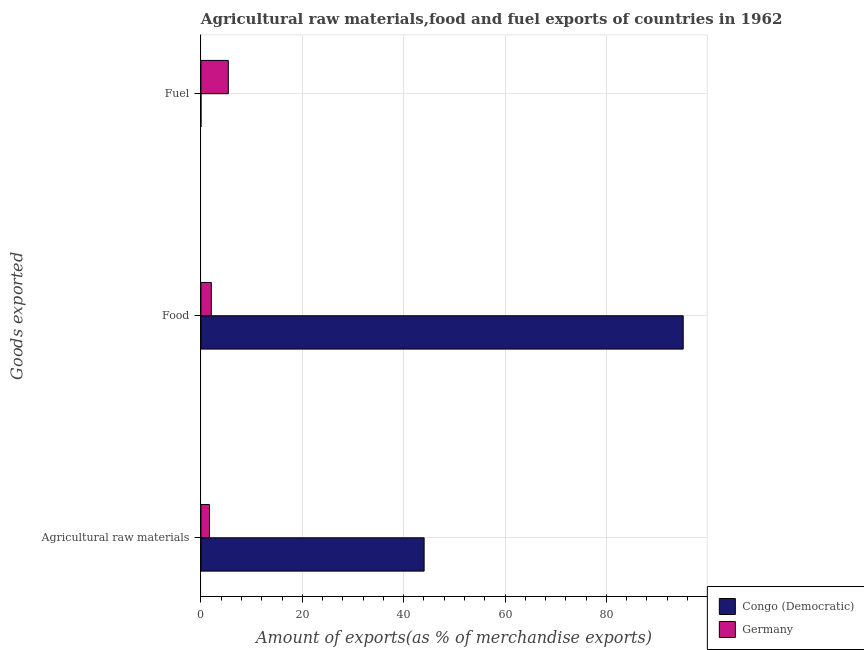How many different coloured bars are there?
Give a very brief answer. 2. Are the number of bars per tick equal to the number of legend labels?
Offer a terse response. Yes. Are the number of bars on each tick of the Y-axis equal?
Provide a short and direct response. Yes. How many bars are there on the 2nd tick from the top?
Offer a very short reply. 2. How many bars are there on the 3rd tick from the bottom?
Give a very brief answer. 2. What is the label of the 2nd group of bars from the top?
Provide a succinct answer. Food. What is the percentage of raw materials exports in Congo (Democratic)?
Provide a succinct answer. 44.04. Across all countries, what is the maximum percentage of raw materials exports?
Keep it short and to the point. 44.04. Across all countries, what is the minimum percentage of fuel exports?
Offer a very short reply. 0. In which country was the percentage of raw materials exports maximum?
Make the answer very short. Congo (Democratic). In which country was the percentage of food exports minimum?
Ensure brevity in your answer.  Germany. What is the total percentage of fuel exports in the graph?
Keep it short and to the point. 5.41. What is the difference between the percentage of fuel exports in Congo (Democratic) and that in Germany?
Provide a succinct answer. -5.4. What is the difference between the percentage of fuel exports in Germany and the percentage of raw materials exports in Congo (Democratic)?
Provide a succinct answer. -38.63. What is the average percentage of fuel exports per country?
Provide a succinct answer. 2.7. What is the difference between the percentage of fuel exports and percentage of food exports in Congo (Democratic)?
Ensure brevity in your answer.  -95.15. In how many countries, is the percentage of food exports greater than 52 %?
Offer a very short reply. 1. What is the ratio of the percentage of fuel exports in Congo (Democratic) to that in Germany?
Give a very brief answer. 0. Is the percentage of fuel exports in Germany less than that in Congo (Democratic)?
Offer a very short reply. No. Is the difference between the percentage of raw materials exports in Congo (Democratic) and Germany greater than the difference between the percentage of food exports in Congo (Democratic) and Germany?
Keep it short and to the point. No. What is the difference between the highest and the second highest percentage of fuel exports?
Your answer should be compact. 5.4. What is the difference between the highest and the lowest percentage of raw materials exports?
Your answer should be very brief. 42.35. What does the 2nd bar from the bottom in Food represents?
Make the answer very short. Germany. Are the values on the major ticks of X-axis written in scientific E-notation?
Keep it short and to the point. No. Does the graph contain any zero values?
Your answer should be very brief. No. Where does the legend appear in the graph?
Offer a very short reply. Bottom right. How many legend labels are there?
Your answer should be very brief. 2. What is the title of the graph?
Make the answer very short. Agricultural raw materials,food and fuel exports of countries in 1962. What is the label or title of the X-axis?
Provide a succinct answer. Amount of exports(as % of merchandise exports). What is the label or title of the Y-axis?
Provide a succinct answer. Goods exported. What is the Amount of exports(as % of merchandise exports) of Congo (Democratic) in Agricultural raw materials?
Offer a very short reply. 44.04. What is the Amount of exports(as % of merchandise exports) in Germany in Agricultural raw materials?
Provide a succinct answer. 1.69. What is the Amount of exports(as % of merchandise exports) in Congo (Democratic) in Food?
Your answer should be compact. 95.15. What is the Amount of exports(as % of merchandise exports) in Germany in Food?
Provide a short and direct response. 2.05. What is the Amount of exports(as % of merchandise exports) in Congo (Democratic) in Fuel?
Provide a short and direct response. 0. What is the Amount of exports(as % of merchandise exports) of Germany in Fuel?
Give a very brief answer. 5.4. Across all Goods exported, what is the maximum Amount of exports(as % of merchandise exports) of Congo (Democratic)?
Your answer should be very brief. 95.15. Across all Goods exported, what is the maximum Amount of exports(as % of merchandise exports) in Germany?
Your answer should be very brief. 5.4. Across all Goods exported, what is the minimum Amount of exports(as % of merchandise exports) in Congo (Democratic)?
Provide a short and direct response. 0. Across all Goods exported, what is the minimum Amount of exports(as % of merchandise exports) in Germany?
Your answer should be compact. 1.69. What is the total Amount of exports(as % of merchandise exports) in Congo (Democratic) in the graph?
Keep it short and to the point. 139.19. What is the total Amount of exports(as % of merchandise exports) in Germany in the graph?
Ensure brevity in your answer.  9.15. What is the difference between the Amount of exports(as % of merchandise exports) of Congo (Democratic) in Agricultural raw materials and that in Food?
Make the answer very short. -51.12. What is the difference between the Amount of exports(as % of merchandise exports) in Germany in Agricultural raw materials and that in Food?
Your response must be concise. -0.36. What is the difference between the Amount of exports(as % of merchandise exports) in Congo (Democratic) in Agricultural raw materials and that in Fuel?
Your response must be concise. 44.04. What is the difference between the Amount of exports(as % of merchandise exports) of Germany in Agricultural raw materials and that in Fuel?
Your answer should be very brief. -3.71. What is the difference between the Amount of exports(as % of merchandise exports) of Congo (Democratic) in Food and that in Fuel?
Make the answer very short. 95.15. What is the difference between the Amount of exports(as % of merchandise exports) of Germany in Food and that in Fuel?
Ensure brevity in your answer.  -3.35. What is the difference between the Amount of exports(as % of merchandise exports) in Congo (Democratic) in Agricultural raw materials and the Amount of exports(as % of merchandise exports) in Germany in Food?
Your answer should be compact. 41.99. What is the difference between the Amount of exports(as % of merchandise exports) of Congo (Democratic) in Agricultural raw materials and the Amount of exports(as % of merchandise exports) of Germany in Fuel?
Keep it short and to the point. 38.63. What is the difference between the Amount of exports(as % of merchandise exports) in Congo (Democratic) in Food and the Amount of exports(as % of merchandise exports) in Germany in Fuel?
Offer a very short reply. 89.75. What is the average Amount of exports(as % of merchandise exports) of Congo (Democratic) per Goods exported?
Make the answer very short. 46.4. What is the average Amount of exports(as % of merchandise exports) of Germany per Goods exported?
Give a very brief answer. 3.05. What is the difference between the Amount of exports(as % of merchandise exports) of Congo (Democratic) and Amount of exports(as % of merchandise exports) of Germany in Agricultural raw materials?
Ensure brevity in your answer.  42.35. What is the difference between the Amount of exports(as % of merchandise exports) of Congo (Democratic) and Amount of exports(as % of merchandise exports) of Germany in Food?
Offer a terse response. 93.1. What is the difference between the Amount of exports(as % of merchandise exports) in Congo (Democratic) and Amount of exports(as % of merchandise exports) in Germany in Fuel?
Your answer should be compact. -5.4. What is the ratio of the Amount of exports(as % of merchandise exports) of Congo (Democratic) in Agricultural raw materials to that in Food?
Your response must be concise. 0.46. What is the ratio of the Amount of exports(as % of merchandise exports) in Germany in Agricultural raw materials to that in Food?
Your answer should be compact. 0.82. What is the ratio of the Amount of exports(as % of merchandise exports) in Congo (Democratic) in Agricultural raw materials to that in Fuel?
Your answer should be compact. 7.92e+04. What is the ratio of the Amount of exports(as % of merchandise exports) in Germany in Agricultural raw materials to that in Fuel?
Offer a very short reply. 0.31. What is the ratio of the Amount of exports(as % of merchandise exports) in Congo (Democratic) in Food to that in Fuel?
Keep it short and to the point. 1.71e+05. What is the ratio of the Amount of exports(as % of merchandise exports) in Germany in Food to that in Fuel?
Make the answer very short. 0.38. What is the difference between the highest and the second highest Amount of exports(as % of merchandise exports) in Congo (Democratic)?
Offer a terse response. 51.12. What is the difference between the highest and the second highest Amount of exports(as % of merchandise exports) of Germany?
Keep it short and to the point. 3.35. What is the difference between the highest and the lowest Amount of exports(as % of merchandise exports) of Congo (Democratic)?
Offer a terse response. 95.15. What is the difference between the highest and the lowest Amount of exports(as % of merchandise exports) in Germany?
Provide a short and direct response. 3.71. 